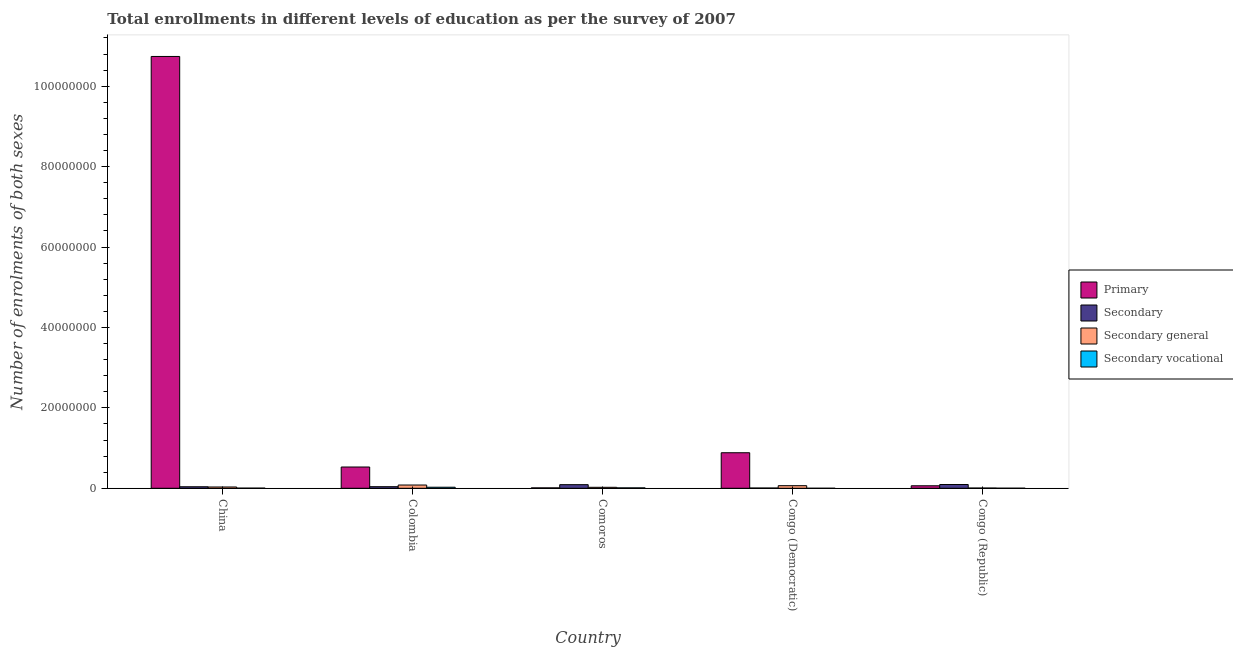How many different coloured bars are there?
Your response must be concise. 4. Are the number of bars per tick equal to the number of legend labels?
Keep it short and to the point. Yes. How many bars are there on the 5th tick from the left?
Your answer should be compact. 4. How many bars are there on the 2nd tick from the right?
Your answer should be very brief. 4. What is the label of the 3rd group of bars from the left?
Your answer should be very brief. Comoros. What is the number of enrolments in secondary education in Congo (Democratic)?
Your answer should be compact. 6.49e+04. Across all countries, what is the maximum number of enrolments in primary education?
Ensure brevity in your answer.  1.07e+08. Across all countries, what is the minimum number of enrolments in secondary vocational education?
Ensure brevity in your answer.  1488. In which country was the number of enrolments in secondary education minimum?
Your answer should be very brief. Congo (Democratic). What is the total number of enrolments in secondary general education in the graph?
Offer a terse response. 2.08e+06. What is the difference between the number of enrolments in secondary general education in Comoros and that in Congo (Democratic)?
Ensure brevity in your answer.  -4.03e+05. What is the difference between the number of enrolments in secondary education in China and the number of enrolments in secondary vocational education in Colombia?
Your response must be concise. 1.16e+05. What is the average number of enrolments in primary education per country?
Your answer should be compact. 2.45e+07. What is the difference between the number of enrolments in secondary education and number of enrolments in secondary general education in Congo (Democratic)?
Your answer should be very brief. -5.81e+05. In how many countries, is the number of enrolments in secondary vocational education greater than 20000000 ?
Give a very brief answer. 0. What is the ratio of the number of enrolments in primary education in Colombia to that in Congo (Democratic)?
Keep it short and to the point. 0.6. What is the difference between the highest and the second highest number of enrolments in secondary vocational education?
Offer a very short reply. 1.57e+05. What is the difference between the highest and the lowest number of enrolments in secondary vocational education?
Give a very brief answer. 2.60e+05. In how many countries, is the number of enrolments in secondary education greater than the average number of enrolments in secondary education taken over all countries?
Make the answer very short. 2. Is the sum of the number of enrolments in primary education in Colombia and Comoros greater than the maximum number of enrolments in secondary general education across all countries?
Provide a short and direct response. Yes. Is it the case that in every country, the sum of the number of enrolments in secondary general education and number of enrolments in secondary vocational education is greater than the sum of number of enrolments in secondary education and number of enrolments in primary education?
Your response must be concise. No. What does the 2nd bar from the left in Comoros represents?
Ensure brevity in your answer.  Secondary. What does the 4th bar from the right in Colombia represents?
Provide a succinct answer. Primary. How many bars are there?
Your response must be concise. 20. What is the difference between two consecutive major ticks on the Y-axis?
Your response must be concise. 2.00e+07. How many legend labels are there?
Offer a terse response. 4. What is the title of the graph?
Keep it short and to the point. Total enrollments in different levels of education as per the survey of 2007. Does "Management rating" appear as one of the legend labels in the graph?
Give a very brief answer. No. What is the label or title of the X-axis?
Provide a succinct answer. Country. What is the label or title of the Y-axis?
Your answer should be very brief. Number of enrolments of both sexes. What is the Number of enrolments of both sexes in Primary in China?
Make the answer very short. 1.07e+08. What is the Number of enrolments of both sexes of Secondary in China?
Your answer should be compact. 3.78e+05. What is the Number of enrolments of both sexes in Secondary general in China?
Provide a succinct answer. 3.20e+05. What is the Number of enrolments of both sexes of Secondary vocational in China?
Ensure brevity in your answer.  3.51e+04. What is the Number of enrolments of both sexes of Primary in Colombia?
Provide a short and direct response. 5.29e+06. What is the Number of enrolments of both sexes of Secondary in Colombia?
Your answer should be very brief. 3.93e+05. What is the Number of enrolments of both sexes of Secondary general in Colombia?
Make the answer very short. 8.08e+05. What is the Number of enrolments of both sexes of Secondary vocational in Colombia?
Give a very brief answer. 2.61e+05. What is the Number of enrolments of both sexes in Primary in Comoros?
Your answer should be very brief. 1.05e+05. What is the Number of enrolments of both sexes of Secondary in Comoros?
Your answer should be compact. 8.99e+05. What is the Number of enrolments of both sexes in Secondary general in Comoros?
Ensure brevity in your answer.  2.43e+05. What is the Number of enrolments of both sexes of Secondary vocational in Comoros?
Provide a succinct answer. 1.04e+05. What is the Number of enrolments of both sexes in Primary in Congo (Democratic)?
Your response must be concise. 8.84e+06. What is the Number of enrolments of both sexes of Secondary in Congo (Democratic)?
Make the answer very short. 6.49e+04. What is the Number of enrolments of both sexes of Secondary general in Congo (Democratic)?
Offer a terse response. 6.46e+05. What is the Number of enrolments of both sexes of Secondary vocational in Congo (Democratic)?
Give a very brief answer. 1488. What is the Number of enrolments of both sexes of Primary in Congo (Republic)?
Make the answer very short. 6.22e+05. What is the Number of enrolments of both sexes of Secondary in Congo (Republic)?
Provide a succinct answer. 9.37e+05. What is the Number of enrolments of both sexes in Secondary general in Congo (Republic)?
Keep it short and to the point. 6.06e+04. What is the Number of enrolments of both sexes of Secondary vocational in Congo (Republic)?
Your answer should be very brief. 1.92e+04. Across all countries, what is the maximum Number of enrolments of both sexes in Primary?
Make the answer very short. 1.07e+08. Across all countries, what is the maximum Number of enrolments of both sexes of Secondary?
Your response must be concise. 9.37e+05. Across all countries, what is the maximum Number of enrolments of both sexes in Secondary general?
Your answer should be very brief. 8.08e+05. Across all countries, what is the maximum Number of enrolments of both sexes of Secondary vocational?
Offer a terse response. 2.61e+05. Across all countries, what is the minimum Number of enrolments of both sexes of Primary?
Your answer should be compact. 1.05e+05. Across all countries, what is the minimum Number of enrolments of both sexes in Secondary?
Provide a succinct answer. 6.49e+04. Across all countries, what is the minimum Number of enrolments of both sexes in Secondary general?
Your answer should be compact. 6.06e+04. Across all countries, what is the minimum Number of enrolments of both sexes of Secondary vocational?
Provide a succinct answer. 1488. What is the total Number of enrolments of both sexes of Primary in the graph?
Give a very brief answer. 1.22e+08. What is the total Number of enrolments of both sexes in Secondary in the graph?
Keep it short and to the point. 2.67e+06. What is the total Number of enrolments of both sexes in Secondary general in the graph?
Your response must be concise. 2.08e+06. What is the total Number of enrolments of both sexes in Secondary vocational in the graph?
Offer a very short reply. 4.21e+05. What is the difference between the Number of enrolments of both sexes of Primary in China and that in Colombia?
Ensure brevity in your answer.  1.02e+08. What is the difference between the Number of enrolments of both sexes in Secondary in China and that in Colombia?
Provide a succinct answer. -1.50e+04. What is the difference between the Number of enrolments of both sexes of Secondary general in China and that in Colombia?
Offer a terse response. -4.88e+05. What is the difference between the Number of enrolments of both sexes of Secondary vocational in China and that in Colombia?
Provide a succinct answer. -2.26e+05. What is the difference between the Number of enrolments of both sexes of Primary in China and that in Comoros?
Give a very brief answer. 1.07e+08. What is the difference between the Number of enrolments of both sexes in Secondary in China and that in Comoros?
Your answer should be very brief. -5.21e+05. What is the difference between the Number of enrolments of both sexes in Secondary general in China and that in Comoros?
Keep it short and to the point. 7.74e+04. What is the difference between the Number of enrolments of both sexes of Secondary vocational in China and that in Comoros?
Ensure brevity in your answer.  -6.90e+04. What is the difference between the Number of enrolments of both sexes in Primary in China and that in Congo (Democratic)?
Provide a short and direct response. 9.86e+07. What is the difference between the Number of enrolments of both sexes of Secondary in China and that in Congo (Democratic)?
Keep it short and to the point. 3.13e+05. What is the difference between the Number of enrolments of both sexes in Secondary general in China and that in Congo (Democratic)?
Offer a very short reply. -3.25e+05. What is the difference between the Number of enrolments of both sexes of Secondary vocational in China and that in Congo (Democratic)?
Give a very brief answer. 3.36e+04. What is the difference between the Number of enrolments of both sexes in Primary in China and that in Congo (Republic)?
Your answer should be compact. 1.07e+08. What is the difference between the Number of enrolments of both sexes in Secondary in China and that in Congo (Republic)?
Provide a succinct answer. -5.59e+05. What is the difference between the Number of enrolments of both sexes of Secondary general in China and that in Congo (Republic)?
Make the answer very short. 2.60e+05. What is the difference between the Number of enrolments of both sexes of Secondary vocational in China and that in Congo (Republic)?
Your answer should be compact. 1.59e+04. What is the difference between the Number of enrolments of both sexes of Primary in Colombia and that in Comoros?
Provide a short and direct response. 5.19e+06. What is the difference between the Number of enrolments of both sexes in Secondary in Colombia and that in Comoros?
Make the answer very short. -5.06e+05. What is the difference between the Number of enrolments of both sexes in Secondary general in Colombia and that in Comoros?
Your answer should be compact. 5.65e+05. What is the difference between the Number of enrolments of both sexes in Secondary vocational in Colombia and that in Comoros?
Offer a terse response. 1.57e+05. What is the difference between the Number of enrolments of both sexes in Primary in Colombia and that in Congo (Democratic)?
Make the answer very short. -3.55e+06. What is the difference between the Number of enrolments of both sexes in Secondary in Colombia and that in Congo (Democratic)?
Ensure brevity in your answer.  3.28e+05. What is the difference between the Number of enrolments of both sexes of Secondary general in Colombia and that in Congo (Democratic)?
Provide a succinct answer. 1.63e+05. What is the difference between the Number of enrolments of both sexes in Secondary vocational in Colombia and that in Congo (Democratic)?
Make the answer very short. 2.60e+05. What is the difference between the Number of enrolments of both sexes in Primary in Colombia and that in Congo (Republic)?
Your answer should be very brief. 4.67e+06. What is the difference between the Number of enrolments of both sexes in Secondary in Colombia and that in Congo (Republic)?
Offer a terse response. -5.44e+05. What is the difference between the Number of enrolments of both sexes in Secondary general in Colombia and that in Congo (Republic)?
Give a very brief answer. 7.48e+05. What is the difference between the Number of enrolments of both sexes of Secondary vocational in Colombia and that in Congo (Republic)?
Keep it short and to the point. 2.42e+05. What is the difference between the Number of enrolments of both sexes of Primary in Comoros and that in Congo (Democratic)?
Your answer should be compact. -8.74e+06. What is the difference between the Number of enrolments of both sexes of Secondary in Comoros and that in Congo (Democratic)?
Provide a short and direct response. 8.34e+05. What is the difference between the Number of enrolments of both sexes in Secondary general in Comoros and that in Congo (Democratic)?
Offer a terse response. -4.03e+05. What is the difference between the Number of enrolments of both sexes of Secondary vocational in Comoros and that in Congo (Democratic)?
Provide a short and direct response. 1.03e+05. What is the difference between the Number of enrolments of both sexes of Primary in Comoros and that in Congo (Republic)?
Your response must be concise. -5.17e+05. What is the difference between the Number of enrolments of both sexes of Secondary in Comoros and that in Congo (Republic)?
Your response must be concise. -3.82e+04. What is the difference between the Number of enrolments of both sexes in Secondary general in Comoros and that in Congo (Republic)?
Offer a terse response. 1.82e+05. What is the difference between the Number of enrolments of both sexes in Secondary vocational in Comoros and that in Congo (Republic)?
Keep it short and to the point. 8.50e+04. What is the difference between the Number of enrolments of both sexes in Primary in Congo (Democratic) and that in Congo (Republic)?
Offer a very short reply. 8.22e+06. What is the difference between the Number of enrolments of both sexes in Secondary in Congo (Democratic) and that in Congo (Republic)?
Offer a very short reply. -8.72e+05. What is the difference between the Number of enrolments of both sexes of Secondary general in Congo (Democratic) and that in Congo (Republic)?
Your answer should be compact. 5.85e+05. What is the difference between the Number of enrolments of both sexes of Secondary vocational in Congo (Democratic) and that in Congo (Republic)?
Keep it short and to the point. -1.77e+04. What is the difference between the Number of enrolments of both sexes of Primary in China and the Number of enrolments of both sexes of Secondary in Colombia?
Your answer should be very brief. 1.07e+08. What is the difference between the Number of enrolments of both sexes in Primary in China and the Number of enrolments of both sexes in Secondary general in Colombia?
Offer a terse response. 1.07e+08. What is the difference between the Number of enrolments of both sexes in Primary in China and the Number of enrolments of both sexes in Secondary vocational in Colombia?
Make the answer very short. 1.07e+08. What is the difference between the Number of enrolments of both sexes in Secondary in China and the Number of enrolments of both sexes in Secondary general in Colombia?
Provide a short and direct response. -4.30e+05. What is the difference between the Number of enrolments of both sexes in Secondary in China and the Number of enrolments of both sexes in Secondary vocational in Colombia?
Make the answer very short. 1.16e+05. What is the difference between the Number of enrolments of both sexes of Secondary general in China and the Number of enrolments of both sexes of Secondary vocational in Colombia?
Provide a succinct answer. 5.90e+04. What is the difference between the Number of enrolments of both sexes in Primary in China and the Number of enrolments of both sexes in Secondary in Comoros?
Give a very brief answer. 1.06e+08. What is the difference between the Number of enrolments of both sexes in Primary in China and the Number of enrolments of both sexes in Secondary general in Comoros?
Offer a very short reply. 1.07e+08. What is the difference between the Number of enrolments of both sexes in Primary in China and the Number of enrolments of both sexes in Secondary vocational in Comoros?
Provide a succinct answer. 1.07e+08. What is the difference between the Number of enrolments of both sexes of Secondary in China and the Number of enrolments of both sexes of Secondary general in Comoros?
Give a very brief answer. 1.35e+05. What is the difference between the Number of enrolments of both sexes of Secondary in China and the Number of enrolments of both sexes of Secondary vocational in Comoros?
Give a very brief answer. 2.74e+05. What is the difference between the Number of enrolments of both sexes of Secondary general in China and the Number of enrolments of both sexes of Secondary vocational in Comoros?
Offer a very short reply. 2.16e+05. What is the difference between the Number of enrolments of both sexes of Primary in China and the Number of enrolments of both sexes of Secondary in Congo (Democratic)?
Your answer should be very brief. 1.07e+08. What is the difference between the Number of enrolments of both sexes in Primary in China and the Number of enrolments of both sexes in Secondary general in Congo (Democratic)?
Your response must be concise. 1.07e+08. What is the difference between the Number of enrolments of both sexes of Primary in China and the Number of enrolments of both sexes of Secondary vocational in Congo (Democratic)?
Ensure brevity in your answer.  1.07e+08. What is the difference between the Number of enrolments of both sexes in Secondary in China and the Number of enrolments of both sexes in Secondary general in Congo (Democratic)?
Offer a very short reply. -2.68e+05. What is the difference between the Number of enrolments of both sexes of Secondary in China and the Number of enrolments of both sexes of Secondary vocational in Congo (Democratic)?
Offer a terse response. 3.76e+05. What is the difference between the Number of enrolments of both sexes in Secondary general in China and the Number of enrolments of both sexes in Secondary vocational in Congo (Democratic)?
Offer a terse response. 3.19e+05. What is the difference between the Number of enrolments of both sexes in Primary in China and the Number of enrolments of both sexes in Secondary in Congo (Republic)?
Provide a succinct answer. 1.06e+08. What is the difference between the Number of enrolments of both sexes of Primary in China and the Number of enrolments of both sexes of Secondary general in Congo (Republic)?
Ensure brevity in your answer.  1.07e+08. What is the difference between the Number of enrolments of both sexes in Primary in China and the Number of enrolments of both sexes in Secondary vocational in Congo (Republic)?
Keep it short and to the point. 1.07e+08. What is the difference between the Number of enrolments of both sexes of Secondary in China and the Number of enrolments of both sexes of Secondary general in Congo (Republic)?
Provide a succinct answer. 3.17e+05. What is the difference between the Number of enrolments of both sexes of Secondary in China and the Number of enrolments of both sexes of Secondary vocational in Congo (Republic)?
Provide a succinct answer. 3.59e+05. What is the difference between the Number of enrolments of both sexes of Secondary general in China and the Number of enrolments of both sexes of Secondary vocational in Congo (Republic)?
Provide a short and direct response. 3.01e+05. What is the difference between the Number of enrolments of both sexes in Primary in Colombia and the Number of enrolments of both sexes in Secondary in Comoros?
Give a very brief answer. 4.39e+06. What is the difference between the Number of enrolments of both sexes in Primary in Colombia and the Number of enrolments of both sexes in Secondary general in Comoros?
Make the answer very short. 5.05e+06. What is the difference between the Number of enrolments of both sexes of Primary in Colombia and the Number of enrolments of both sexes of Secondary vocational in Comoros?
Offer a very short reply. 5.19e+06. What is the difference between the Number of enrolments of both sexes of Secondary in Colombia and the Number of enrolments of both sexes of Secondary general in Comoros?
Ensure brevity in your answer.  1.50e+05. What is the difference between the Number of enrolments of both sexes of Secondary in Colombia and the Number of enrolments of both sexes of Secondary vocational in Comoros?
Provide a succinct answer. 2.89e+05. What is the difference between the Number of enrolments of both sexes in Secondary general in Colombia and the Number of enrolments of both sexes in Secondary vocational in Comoros?
Give a very brief answer. 7.04e+05. What is the difference between the Number of enrolments of both sexes in Primary in Colombia and the Number of enrolments of both sexes in Secondary in Congo (Democratic)?
Ensure brevity in your answer.  5.23e+06. What is the difference between the Number of enrolments of both sexes of Primary in Colombia and the Number of enrolments of both sexes of Secondary general in Congo (Democratic)?
Give a very brief answer. 4.65e+06. What is the difference between the Number of enrolments of both sexes in Primary in Colombia and the Number of enrolments of both sexes in Secondary vocational in Congo (Democratic)?
Ensure brevity in your answer.  5.29e+06. What is the difference between the Number of enrolments of both sexes of Secondary in Colombia and the Number of enrolments of both sexes of Secondary general in Congo (Democratic)?
Your response must be concise. -2.53e+05. What is the difference between the Number of enrolments of both sexes of Secondary in Colombia and the Number of enrolments of both sexes of Secondary vocational in Congo (Democratic)?
Ensure brevity in your answer.  3.91e+05. What is the difference between the Number of enrolments of both sexes in Secondary general in Colombia and the Number of enrolments of both sexes in Secondary vocational in Congo (Democratic)?
Provide a succinct answer. 8.07e+05. What is the difference between the Number of enrolments of both sexes in Primary in Colombia and the Number of enrolments of both sexes in Secondary in Congo (Republic)?
Ensure brevity in your answer.  4.36e+06. What is the difference between the Number of enrolments of both sexes in Primary in Colombia and the Number of enrolments of both sexes in Secondary general in Congo (Republic)?
Your answer should be very brief. 5.23e+06. What is the difference between the Number of enrolments of both sexes of Primary in Colombia and the Number of enrolments of both sexes of Secondary vocational in Congo (Republic)?
Ensure brevity in your answer.  5.27e+06. What is the difference between the Number of enrolments of both sexes of Secondary in Colombia and the Number of enrolments of both sexes of Secondary general in Congo (Republic)?
Offer a terse response. 3.32e+05. What is the difference between the Number of enrolments of both sexes of Secondary in Colombia and the Number of enrolments of both sexes of Secondary vocational in Congo (Republic)?
Make the answer very short. 3.74e+05. What is the difference between the Number of enrolments of both sexes in Secondary general in Colombia and the Number of enrolments of both sexes in Secondary vocational in Congo (Republic)?
Make the answer very short. 7.89e+05. What is the difference between the Number of enrolments of both sexes in Primary in Comoros and the Number of enrolments of both sexes in Secondary in Congo (Democratic)?
Provide a short and direct response. 3.97e+04. What is the difference between the Number of enrolments of both sexes of Primary in Comoros and the Number of enrolments of both sexes of Secondary general in Congo (Democratic)?
Offer a terse response. -5.41e+05. What is the difference between the Number of enrolments of both sexes of Primary in Comoros and the Number of enrolments of both sexes of Secondary vocational in Congo (Democratic)?
Make the answer very short. 1.03e+05. What is the difference between the Number of enrolments of both sexes in Secondary in Comoros and the Number of enrolments of both sexes in Secondary general in Congo (Democratic)?
Your answer should be compact. 2.53e+05. What is the difference between the Number of enrolments of both sexes of Secondary in Comoros and the Number of enrolments of both sexes of Secondary vocational in Congo (Democratic)?
Offer a very short reply. 8.97e+05. What is the difference between the Number of enrolments of both sexes of Secondary general in Comoros and the Number of enrolments of both sexes of Secondary vocational in Congo (Democratic)?
Your response must be concise. 2.42e+05. What is the difference between the Number of enrolments of both sexes in Primary in Comoros and the Number of enrolments of both sexes in Secondary in Congo (Republic)?
Ensure brevity in your answer.  -8.33e+05. What is the difference between the Number of enrolments of both sexes in Primary in Comoros and the Number of enrolments of both sexes in Secondary general in Congo (Republic)?
Your answer should be very brief. 4.39e+04. What is the difference between the Number of enrolments of both sexes in Primary in Comoros and the Number of enrolments of both sexes in Secondary vocational in Congo (Republic)?
Offer a terse response. 8.53e+04. What is the difference between the Number of enrolments of both sexes in Secondary in Comoros and the Number of enrolments of both sexes in Secondary general in Congo (Republic)?
Provide a short and direct response. 8.38e+05. What is the difference between the Number of enrolments of both sexes of Secondary in Comoros and the Number of enrolments of both sexes of Secondary vocational in Congo (Republic)?
Provide a short and direct response. 8.80e+05. What is the difference between the Number of enrolments of both sexes in Secondary general in Comoros and the Number of enrolments of both sexes in Secondary vocational in Congo (Republic)?
Make the answer very short. 2.24e+05. What is the difference between the Number of enrolments of both sexes in Primary in Congo (Democratic) and the Number of enrolments of both sexes in Secondary in Congo (Republic)?
Your answer should be very brief. 7.90e+06. What is the difference between the Number of enrolments of both sexes of Primary in Congo (Democratic) and the Number of enrolments of both sexes of Secondary general in Congo (Republic)?
Provide a succinct answer. 8.78e+06. What is the difference between the Number of enrolments of both sexes of Primary in Congo (Democratic) and the Number of enrolments of both sexes of Secondary vocational in Congo (Republic)?
Make the answer very short. 8.82e+06. What is the difference between the Number of enrolments of both sexes in Secondary in Congo (Democratic) and the Number of enrolments of both sexes in Secondary general in Congo (Republic)?
Make the answer very short. 4204. What is the difference between the Number of enrolments of both sexes in Secondary in Congo (Democratic) and the Number of enrolments of both sexes in Secondary vocational in Congo (Republic)?
Make the answer very short. 4.57e+04. What is the difference between the Number of enrolments of both sexes of Secondary general in Congo (Democratic) and the Number of enrolments of both sexes of Secondary vocational in Congo (Republic)?
Offer a very short reply. 6.26e+05. What is the average Number of enrolments of both sexes in Primary per country?
Keep it short and to the point. 2.45e+07. What is the average Number of enrolments of both sexes in Secondary per country?
Ensure brevity in your answer.  5.34e+05. What is the average Number of enrolments of both sexes of Secondary general per country?
Your answer should be compact. 4.16e+05. What is the average Number of enrolments of both sexes in Secondary vocational per country?
Keep it short and to the point. 8.43e+04. What is the difference between the Number of enrolments of both sexes in Primary and Number of enrolments of both sexes in Secondary in China?
Give a very brief answer. 1.07e+08. What is the difference between the Number of enrolments of both sexes of Primary and Number of enrolments of both sexes of Secondary general in China?
Provide a short and direct response. 1.07e+08. What is the difference between the Number of enrolments of both sexes of Primary and Number of enrolments of both sexes of Secondary vocational in China?
Offer a terse response. 1.07e+08. What is the difference between the Number of enrolments of both sexes of Secondary and Number of enrolments of both sexes of Secondary general in China?
Your answer should be compact. 5.74e+04. What is the difference between the Number of enrolments of both sexes in Secondary and Number of enrolments of both sexes in Secondary vocational in China?
Provide a short and direct response. 3.43e+05. What is the difference between the Number of enrolments of both sexes in Secondary general and Number of enrolments of both sexes in Secondary vocational in China?
Make the answer very short. 2.85e+05. What is the difference between the Number of enrolments of both sexes of Primary and Number of enrolments of both sexes of Secondary in Colombia?
Provide a succinct answer. 4.90e+06. What is the difference between the Number of enrolments of both sexes in Primary and Number of enrolments of both sexes in Secondary general in Colombia?
Your response must be concise. 4.48e+06. What is the difference between the Number of enrolments of both sexes of Primary and Number of enrolments of both sexes of Secondary vocational in Colombia?
Your answer should be very brief. 5.03e+06. What is the difference between the Number of enrolments of both sexes of Secondary and Number of enrolments of both sexes of Secondary general in Colombia?
Offer a terse response. -4.15e+05. What is the difference between the Number of enrolments of both sexes in Secondary and Number of enrolments of both sexes in Secondary vocational in Colombia?
Provide a short and direct response. 1.32e+05. What is the difference between the Number of enrolments of both sexes in Secondary general and Number of enrolments of both sexes in Secondary vocational in Colombia?
Your response must be concise. 5.47e+05. What is the difference between the Number of enrolments of both sexes in Primary and Number of enrolments of both sexes in Secondary in Comoros?
Offer a very short reply. -7.94e+05. What is the difference between the Number of enrolments of both sexes in Primary and Number of enrolments of both sexes in Secondary general in Comoros?
Ensure brevity in your answer.  -1.39e+05. What is the difference between the Number of enrolments of both sexes in Primary and Number of enrolments of both sexes in Secondary vocational in Comoros?
Offer a terse response. 353. What is the difference between the Number of enrolments of both sexes in Secondary and Number of enrolments of both sexes in Secondary general in Comoros?
Offer a very short reply. 6.56e+05. What is the difference between the Number of enrolments of both sexes of Secondary and Number of enrolments of both sexes of Secondary vocational in Comoros?
Provide a short and direct response. 7.95e+05. What is the difference between the Number of enrolments of both sexes in Secondary general and Number of enrolments of both sexes in Secondary vocational in Comoros?
Give a very brief answer. 1.39e+05. What is the difference between the Number of enrolments of both sexes of Primary and Number of enrolments of both sexes of Secondary in Congo (Democratic)?
Give a very brief answer. 8.78e+06. What is the difference between the Number of enrolments of both sexes in Primary and Number of enrolments of both sexes in Secondary general in Congo (Democratic)?
Your answer should be compact. 8.19e+06. What is the difference between the Number of enrolments of both sexes of Primary and Number of enrolments of both sexes of Secondary vocational in Congo (Democratic)?
Ensure brevity in your answer.  8.84e+06. What is the difference between the Number of enrolments of both sexes in Secondary and Number of enrolments of both sexes in Secondary general in Congo (Democratic)?
Your response must be concise. -5.81e+05. What is the difference between the Number of enrolments of both sexes of Secondary and Number of enrolments of both sexes of Secondary vocational in Congo (Democratic)?
Give a very brief answer. 6.34e+04. What is the difference between the Number of enrolments of both sexes of Secondary general and Number of enrolments of both sexes of Secondary vocational in Congo (Democratic)?
Offer a terse response. 6.44e+05. What is the difference between the Number of enrolments of both sexes of Primary and Number of enrolments of both sexes of Secondary in Congo (Republic)?
Give a very brief answer. -3.15e+05. What is the difference between the Number of enrolments of both sexes in Primary and Number of enrolments of both sexes in Secondary general in Congo (Republic)?
Offer a terse response. 5.61e+05. What is the difference between the Number of enrolments of both sexes in Primary and Number of enrolments of both sexes in Secondary vocational in Congo (Republic)?
Provide a succinct answer. 6.03e+05. What is the difference between the Number of enrolments of both sexes of Secondary and Number of enrolments of both sexes of Secondary general in Congo (Republic)?
Provide a succinct answer. 8.76e+05. What is the difference between the Number of enrolments of both sexes of Secondary and Number of enrolments of both sexes of Secondary vocational in Congo (Republic)?
Your response must be concise. 9.18e+05. What is the difference between the Number of enrolments of both sexes of Secondary general and Number of enrolments of both sexes of Secondary vocational in Congo (Republic)?
Your answer should be very brief. 4.15e+04. What is the ratio of the Number of enrolments of both sexes of Primary in China to that in Colombia?
Ensure brevity in your answer.  20.29. What is the ratio of the Number of enrolments of both sexes of Secondary in China to that in Colombia?
Your answer should be compact. 0.96. What is the ratio of the Number of enrolments of both sexes of Secondary general in China to that in Colombia?
Provide a succinct answer. 0.4. What is the ratio of the Number of enrolments of both sexes in Secondary vocational in China to that in Colombia?
Your response must be concise. 0.13. What is the ratio of the Number of enrolments of both sexes in Primary in China to that in Comoros?
Offer a very short reply. 1027.52. What is the ratio of the Number of enrolments of both sexes in Secondary in China to that in Comoros?
Offer a very short reply. 0.42. What is the ratio of the Number of enrolments of both sexes of Secondary general in China to that in Comoros?
Keep it short and to the point. 1.32. What is the ratio of the Number of enrolments of both sexes of Secondary vocational in China to that in Comoros?
Your answer should be very brief. 0.34. What is the ratio of the Number of enrolments of both sexes of Primary in China to that in Congo (Democratic)?
Your answer should be compact. 12.15. What is the ratio of the Number of enrolments of both sexes in Secondary in China to that in Congo (Democratic)?
Provide a short and direct response. 5.83. What is the ratio of the Number of enrolments of both sexes of Secondary general in China to that in Congo (Democratic)?
Your answer should be very brief. 0.5. What is the ratio of the Number of enrolments of both sexes in Secondary vocational in China to that in Congo (Democratic)?
Your response must be concise. 23.6. What is the ratio of the Number of enrolments of both sexes of Primary in China to that in Congo (Republic)?
Ensure brevity in your answer.  172.74. What is the ratio of the Number of enrolments of both sexes in Secondary in China to that in Congo (Republic)?
Ensure brevity in your answer.  0.4. What is the ratio of the Number of enrolments of both sexes in Secondary general in China to that in Congo (Republic)?
Offer a very short reply. 5.28. What is the ratio of the Number of enrolments of both sexes in Secondary vocational in China to that in Congo (Republic)?
Give a very brief answer. 1.83. What is the ratio of the Number of enrolments of both sexes of Primary in Colombia to that in Comoros?
Make the answer very short. 50.64. What is the ratio of the Number of enrolments of both sexes in Secondary in Colombia to that in Comoros?
Provide a succinct answer. 0.44. What is the ratio of the Number of enrolments of both sexes in Secondary general in Colombia to that in Comoros?
Keep it short and to the point. 3.33. What is the ratio of the Number of enrolments of both sexes in Secondary vocational in Colombia to that in Comoros?
Offer a very short reply. 2.51. What is the ratio of the Number of enrolments of both sexes in Primary in Colombia to that in Congo (Democratic)?
Your answer should be very brief. 0.6. What is the ratio of the Number of enrolments of both sexes of Secondary in Colombia to that in Congo (Democratic)?
Keep it short and to the point. 6.06. What is the ratio of the Number of enrolments of both sexes in Secondary general in Colombia to that in Congo (Democratic)?
Offer a terse response. 1.25. What is the ratio of the Number of enrolments of both sexes of Secondary vocational in Colombia to that in Congo (Democratic)?
Provide a short and direct response. 175.7. What is the ratio of the Number of enrolments of both sexes of Primary in Colombia to that in Congo (Republic)?
Your answer should be very brief. 8.51. What is the ratio of the Number of enrolments of both sexes of Secondary in Colombia to that in Congo (Republic)?
Offer a terse response. 0.42. What is the ratio of the Number of enrolments of both sexes in Secondary general in Colombia to that in Congo (Republic)?
Keep it short and to the point. 13.33. What is the ratio of the Number of enrolments of both sexes of Secondary vocational in Colombia to that in Congo (Republic)?
Your response must be concise. 13.64. What is the ratio of the Number of enrolments of both sexes in Primary in Comoros to that in Congo (Democratic)?
Your response must be concise. 0.01. What is the ratio of the Number of enrolments of both sexes in Secondary in Comoros to that in Congo (Democratic)?
Your answer should be compact. 13.86. What is the ratio of the Number of enrolments of both sexes in Secondary general in Comoros to that in Congo (Democratic)?
Make the answer very short. 0.38. What is the ratio of the Number of enrolments of both sexes in Secondary vocational in Comoros to that in Congo (Democratic)?
Provide a succinct answer. 70. What is the ratio of the Number of enrolments of both sexes in Primary in Comoros to that in Congo (Republic)?
Your answer should be very brief. 0.17. What is the ratio of the Number of enrolments of both sexes in Secondary in Comoros to that in Congo (Republic)?
Give a very brief answer. 0.96. What is the ratio of the Number of enrolments of both sexes of Secondary general in Comoros to that in Congo (Republic)?
Provide a succinct answer. 4.01. What is the ratio of the Number of enrolments of both sexes of Secondary vocational in Comoros to that in Congo (Republic)?
Offer a very short reply. 5.43. What is the ratio of the Number of enrolments of both sexes in Primary in Congo (Democratic) to that in Congo (Republic)?
Give a very brief answer. 14.22. What is the ratio of the Number of enrolments of both sexes in Secondary in Congo (Democratic) to that in Congo (Republic)?
Ensure brevity in your answer.  0.07. What is the ratio of the Number of enrolments of both sexes of Secondary general in Congo (Democratic) to that in Congo (Republic)?
Your response must be concise. 10.65. What is the ratio of the Number of enrolments of both sexes in Secondary vocational in Congo (Democratic) to that in Congo (Republic)?
Make the answer very short. 0.08. What is the difference between the highest and the second highest Number of enrolments of both sexes of Primary?
Your answer should be very brief. 9.86e+07. What is the difference between the highest and the second highest Number of enrolments of both sexes of Secondary?
Offer a very short reply. 3.82e+04. What is the difference between the highest and the second highest Number of enrolments of both sexes of Secondary general?
Ensure brevity in your answer.  1.63e+05. What is the difference between the highest and the second highest Number of enrolments of both sexes in Secondary vocational?
Your response must be concise. 1.57e+05. What is the difference between the highest and the lowest Number of enrolments of both sexes in Primary?
Your answer should be compact. 1.07e+08. What is the difference between the highest and the lowest Number of enrolments of both sexes of Secondary?
Provide a short and direct response. 8.72e+05. What is the difference between the highest and the lowest Number of enrolments of both sexes of Secondary general?
Your answer should be compact. 7.48e+05. What is the difference between the highest and the lowest Number of enrolments of both sexes of Secondary vocational?
Your answer should be compact. 2.60e+05. 